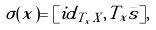<formula> <loc_0><loc_0><loc_500><loc_500>\sigma ( x ) = [ i d _ { T _ { x } X } , T _ { x } \bar { s } ] ,</formula> 